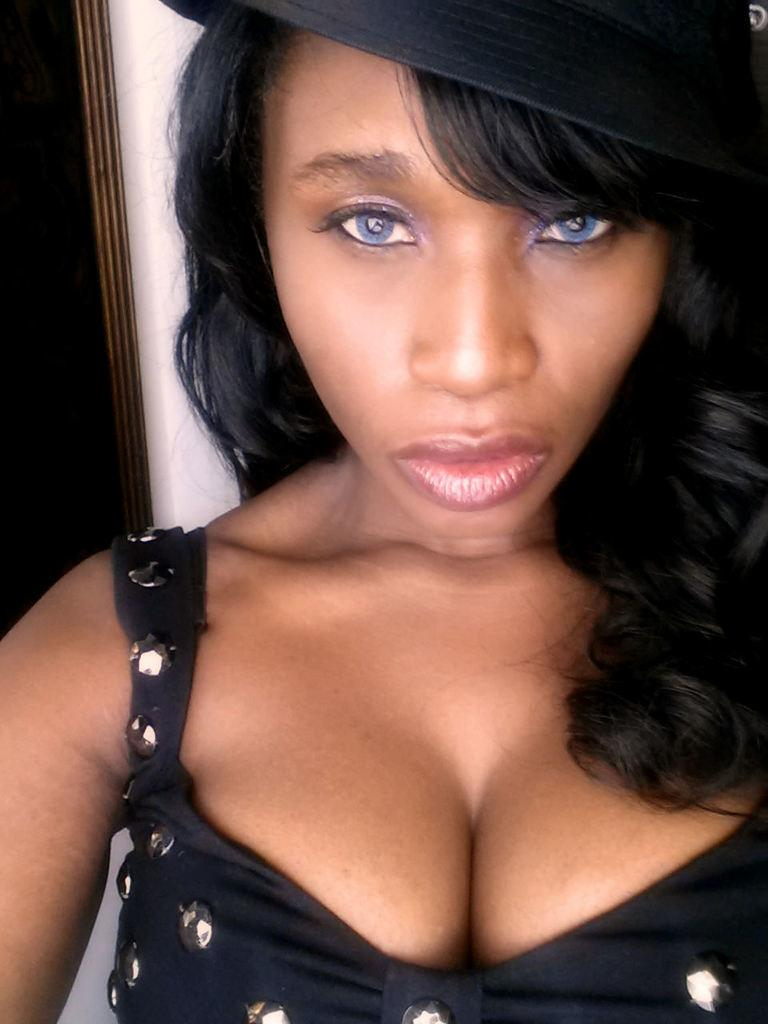Who is present in the image? There is a woman in the image. What can be seen in the background of the image? There is a wall in the background of the image. What type of oatmeal is the woman eating in the image? There is no oatmeal present in the image, and the woman is not eating anything. Can you see a cat in the image? There is no cat present in the image. 